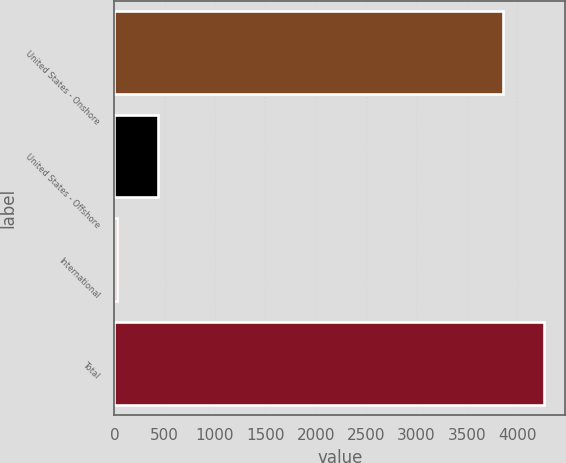Convert chart. <chart><loc_0><loc_0><loc_500><loc_500><bar_chart><fcel>United States - Onshore<fcel>United States - Offshore<fcel>International<fcel>Total<nl><fcel>3860<fcel>431.1<fcel>28<fcel>4263.1<nl></chart> 